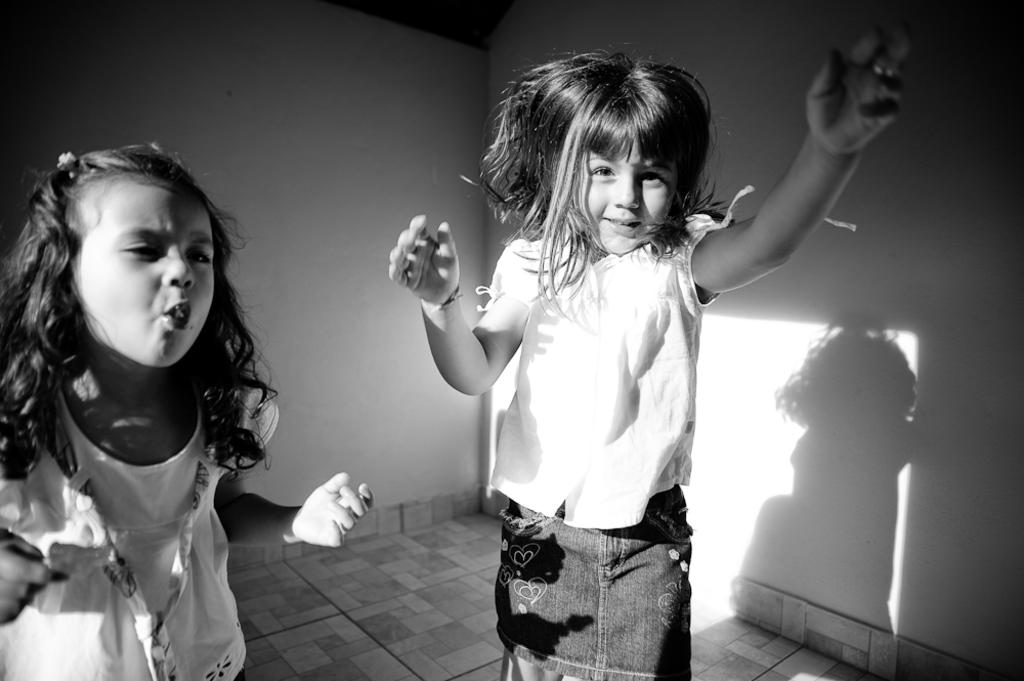How many people are in the image? There are two girls in the image. What are the girls doing in the image? The girls are standing. What is the color scheme of the image? The image is in black and white. What is behind the girls in the image? There is a wall behind the girls. What can be seen on the wall in the image? There is a shadow on the wall to the right. What type of punishment is being depicted in the image? There is no punishment being depicted in the image; it features two girls standing in front of a wall. What sign is visible on the wall in the image? There is no sign visible on the wall in the image; only a shadow can be seen. 